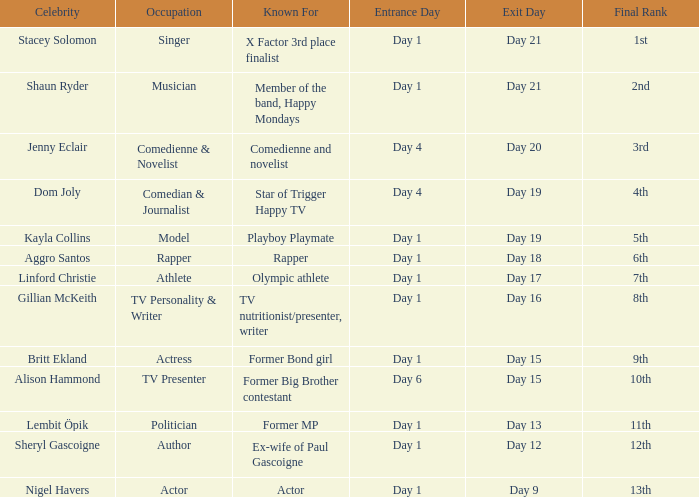For what is dom joly renowned? Comedian, journalist and star of Trigger Happy TV. 